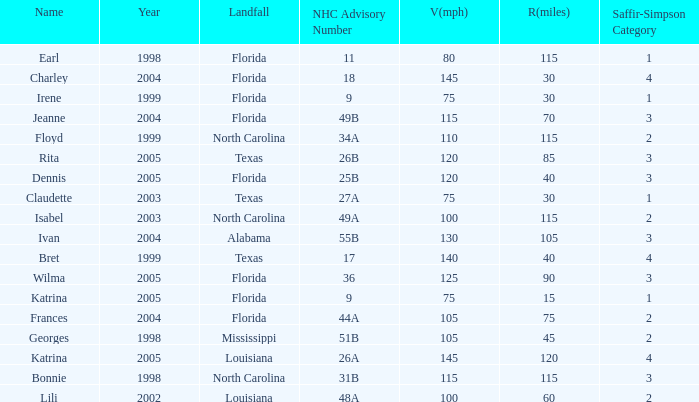What was the lowest V(mph) for a Saffir-Simpson of 4 in 2005? 145.0. 